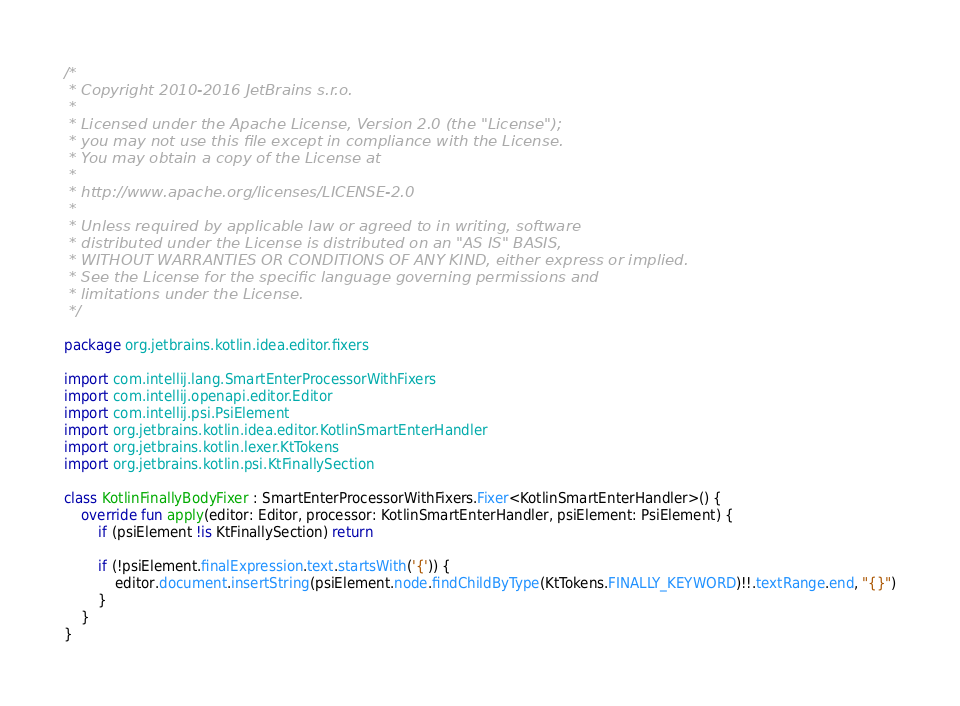Convert code to text. <code><loc_0><loc_0><loc_500><loc_500><_Kotlin_>/*
 * Copyright 2010-2016 JetBrains s.r.o.
 *
 * Licensed under the Apache License, Version 2.0 (the "License");
 * you may not use this file except in compliance with the License.
 * You may obtain a copy of the License at
 *
 * http://www.apache.org/licenses/LICENSE-2.0
 *
 * Unless required by applicable law or agreed to in writing, software
 * distributed under the License is distributed on an "AS IS" BASIS,
 * WITHOUT WARRANTIES OR CONDITIONS OF ANY KIND, either express or implied.
 * See the License for the specific language governing permissions and
 * limitations under the License.
 */

package org.jetbrains.kotlin.idea.editor.fixers

import com.intellij.lang.SmartEnterProcessorWithFixers
import com.intellij.openapi.editor.Editor
import com.intellij.psi.PsiElement
import org.jetbrains.kotlin.idea.editor.KotlinSmartEnterHandler
import org.jetbrains.kotlin.lexer.KtTokens
import org.jetbrains.kotlin.psi.KtFinallySection

class KotlinFinallyBodyFixer : SmartEnterProcessorWithFixers.Fixer<KotlinSmartEnterHandler>() {
    override fun apply(editor: Editor, processor: KotlinSmartEnterHandler, psiElement: PsiElement) {
        if (psiElement !is KtFinallySection) return

        if (!psiElement.finalExpression.text.startsWith('{')) {
            editor.document.insertString(psiElement.node.findChildByType(KtTokens.FINALLY_KEYWORD)!!.textRange.end, "{}")
        }
    }
}</code> 